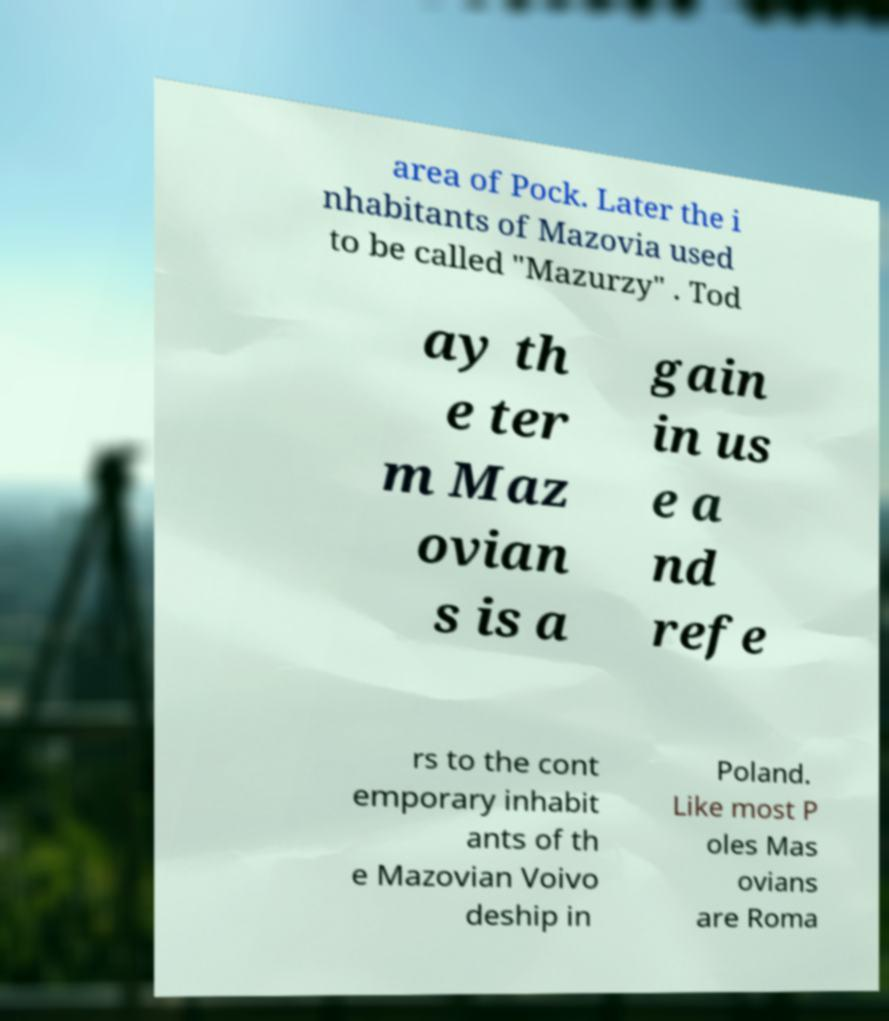There's text embedded in this image that I need extracted. Can you transcribe it verbatim? area of Pock. Later the i nhabitants of Mazovia used to be called "Mazurzy" . Tod ay th e ter m Maz ovian s is a gain in us e a nd refe rs to the cont emporary inhabit ants of th e Mazovian Voivo deship in Poland. Like most P oles Mas ovians are Roma 